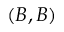Convert formula to latex. <formula><loc_0><loc_0><loc_500><loc_500>( B , B )</formula> 